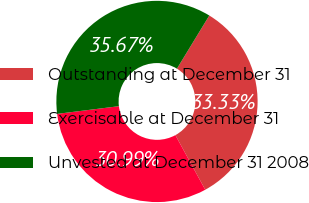Convert chart. <chart><loc_0><loc_0><loc_500><loc_500><pie_chart><fcel>Outstanding at December 31<fcel>Exercisable at December 31<fcel>Unvested at December 31 2008<nl><fcel>33.33%<fcel>30.99%<fcel>35.67%<nl></chart> 